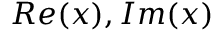<formula> <loc_0><loc_0><loc_500><loc_500>R e ( x ) , I m ( x )</formula> 